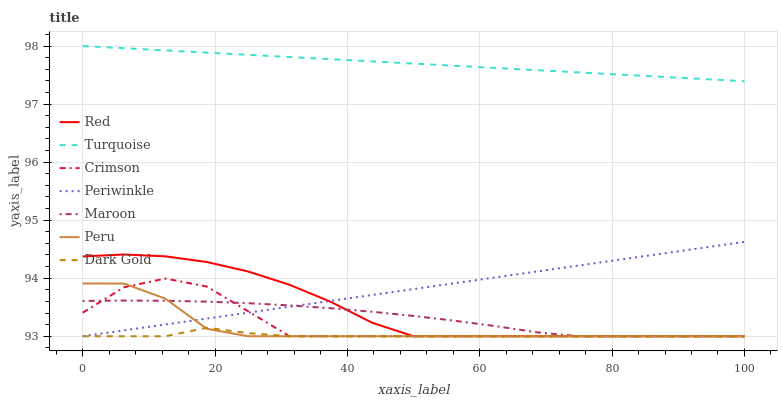Does Dark Gold have the minimum area under the curve?
Answer yes or no. Yes. Does Turquoise have the maximum area under the curve?
Answer yes or no. Yes. Does Maroon have the minimum area under the curve?
Answer yes or no. No. Does Maroon have the maximum area under the curve?
Answer yes or no. No. Is Periwinkle the smoothest?
Answer yes or no. Yes. Is Crimson the roughest?
Answer yes or no. Yes. Is Dark Gold the smoothest?
Answer yes or no. No. Is Dark Gold the roughest?
Answer yes or no. No. Does Dark Gold have the lowest value?
Answer yes or no. Yes. Does Turquoise have the highest value?
Answer yes or no. Yes. Does Maroon have the highest value?
Answer yes or no. No. Is Periwinkle less than Turquoise?
Answer yes or no. Yes. Is Turquoise greater than Periwinkle?
Answer yes or no. Yes. Does Peru intersect Periwinkle?
Answer yes or no. Yes. Is Peru less than Periwinkle?
Answer yes or no. No. Is Peru greater than Periwinkle?
Answer yes or no. No. Does Periwinkle intersect Turquoise?
Answer yes or no. No. 